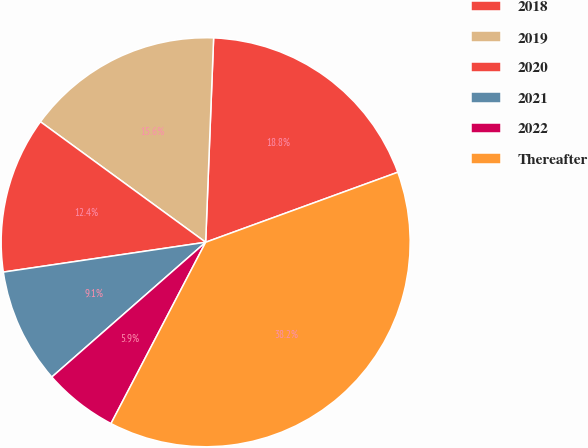Convert chart to OTSL. <chart><loc_0><loc_0><loc_500><loc_500><pie_chart><fcel>2018<fcel>2019<fcel>2020<fcel>2021<fcel>2022<fcel>Thereafter<nl><fcel>18.82%<fcel>15.59%<fcel>12.36%<fcel>9.12%<fcel>5.89%<fcel>38.22%<nl></chart> 